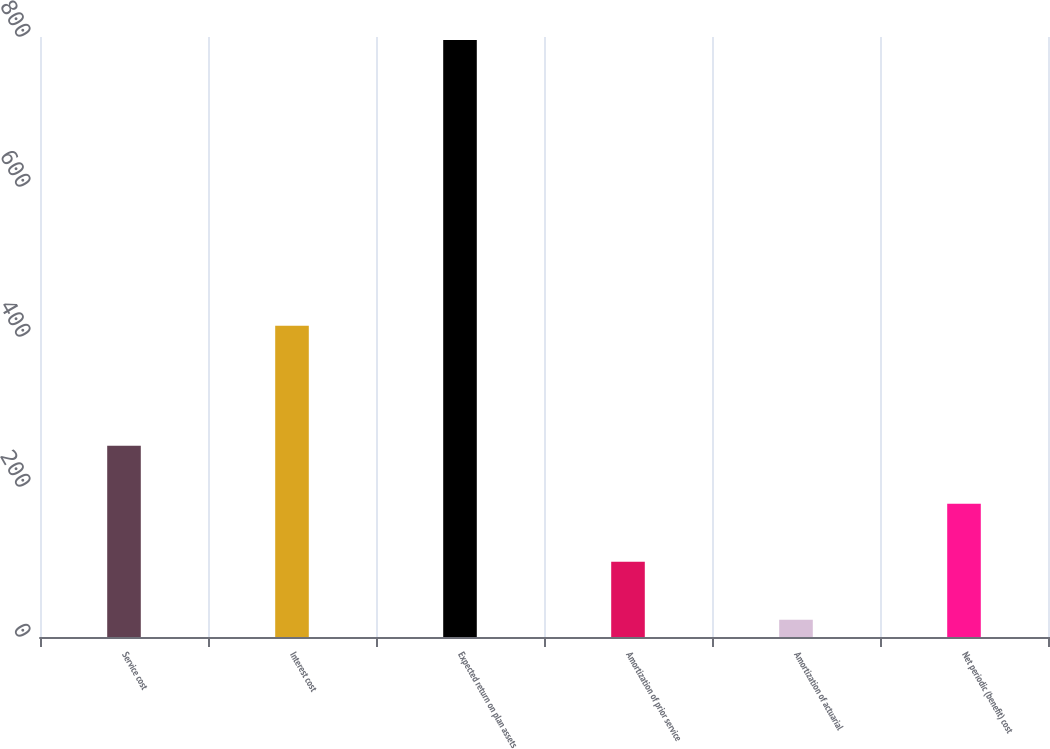Convert chart to OTSL. <chart><loc_0><loc_0><loc_500><loc_500><bar_chart><fcel>Service cost<fcel>Interest cost<fcel>Expected return on plan assets<fcel>Amortization of prior service<fcel>Amortization of actuarial<fcel>Net periodic (benefit) cost<nl><fcel>254.9<fcel>415<fcel>796<fcel>100.3<fcel>23<fcel>177.6<nl></chart> 